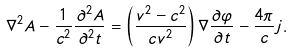Convert formula to latex. <formula><loc_0><loc_0><loc_500><loc_500>\nabla ^ { 2 } { A } - \frac { 1 } { c ^ { 2 } } \frac { \partial ^ { 2 } { A } } { \partial ^ { 2 } t } = \left ( \frac { v ^ { 2 } - c ^ { 2 } } { c v ^ { 2 } } \right ) \nabla \frac { \partial \varphi } { \partial t } - \frac { 4 \pi } { c } { j } .</formula> 